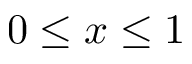Convert formula to latex. <formula><loc_0><loc_0><loc_500><loc_500>0 \leq x \leq 1</formula> 